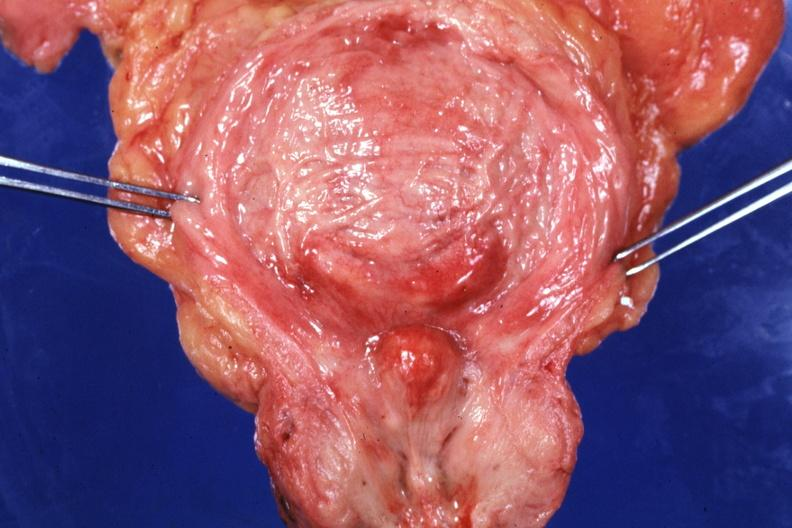does this image show opened bladder with median lobe protruding into trigone area also had increase bladder trabeculations very good slide?
Answer the question using a single word or phrase. Yes 